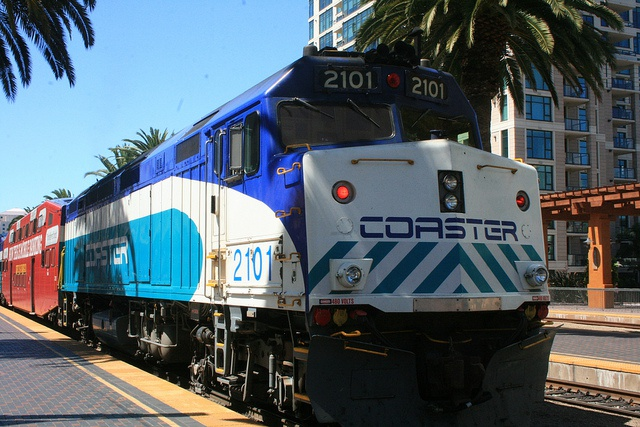Describe the objects in this image and their specific colors. I can see a train in gray, black, and white tones in this image. 